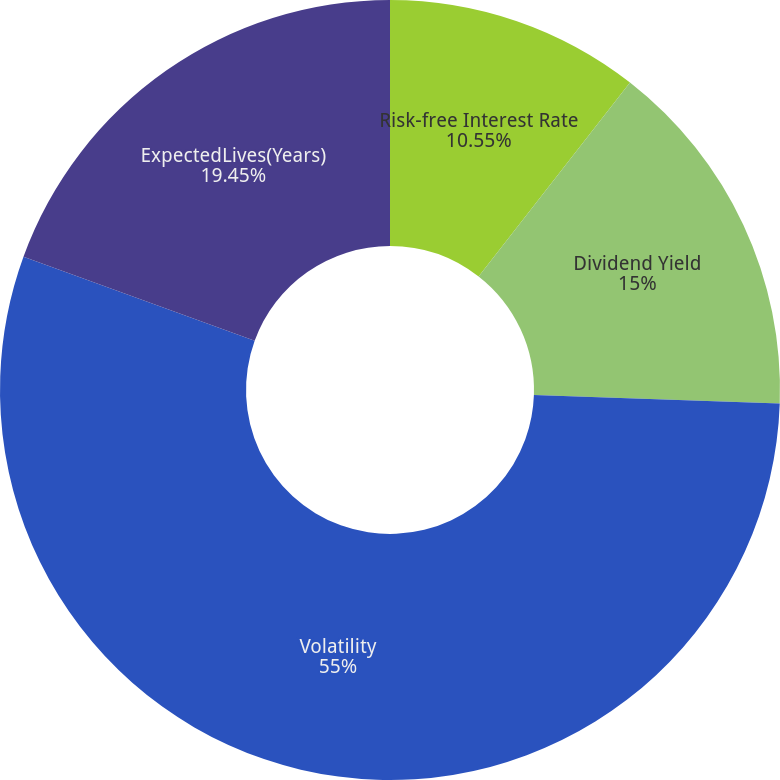<chart> <loc_0><loc_0><loc_500><loc_500><pie_chart><fcel>Risk-free Interest Rate<fcel>Dividend Yield<fcel>Volatility<fcel>ExpectedLives(Years)<nl><fcel>10.55%<fcel>15.0%<fcel>55.0%<fcel>19.45%<nl></chart> 